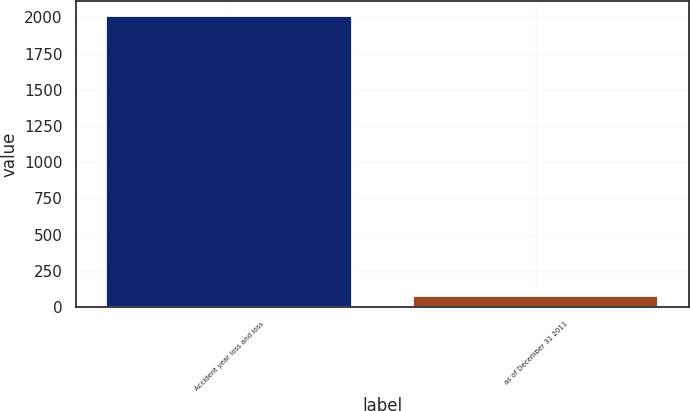<chart> <loc_0><loc_0><loc_500><loc_500><bar_chart><fcel>Accident year loss and loss<fcel>as of December 31 2011<nl><fcel>2011<fcel>79.7<nl></chart> 